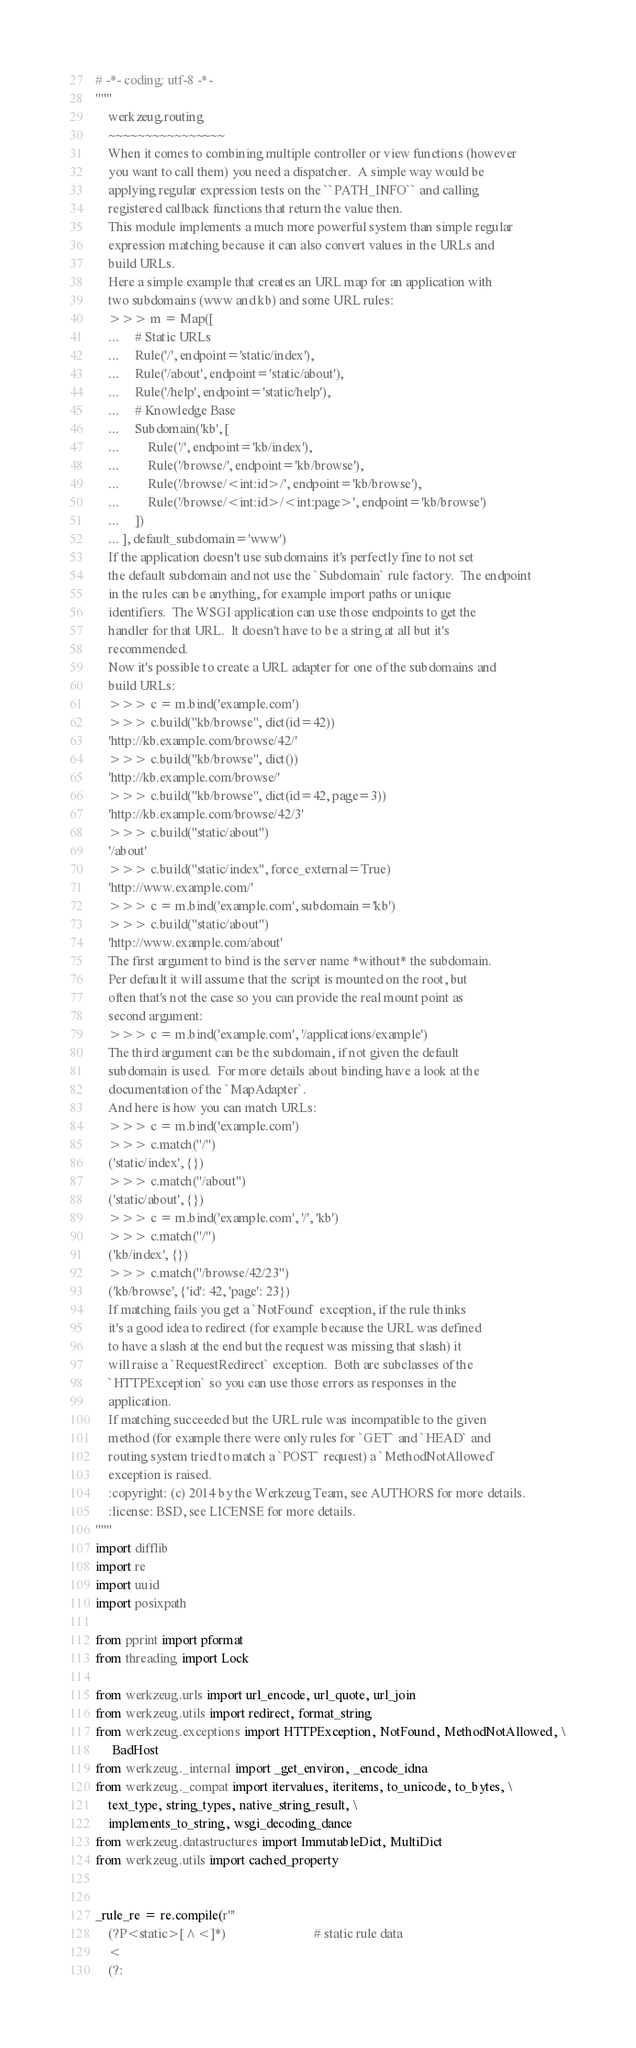<code> <loc_0><loc_0><loc_500><loc_500><_Python_># -*- coding: utf-8 -*-
"""
    werkzeug.routing
    ~~~~~~~~~~~~~~~~
    When it comes to combining multiple controller or view functions (however
    you want to call them) you need a dispatcher.  A simple way would be
    applying regular expression tests on the ``PATH_INFO`` and calling
    registered callback functions that return the value then.
    This module implements a much more powerful system than simple regular
    expression matching because it can also convert values in the URLs and
    build URLs.
    Here a simple example that creates an URL map for an application with
    two subdomains (www and kb) and some URL rules:
    >>> m = Map([
    ...     # Static URLs
    ...     Rule('/', endpoint='static/index'),
    ...     Rule('/about', endpoint='static/about'),
    ...     Rule('/help', endpoint='static/help'),
    ...     # Knowledge Base
    ...     Subdomain('kb', [
    ...         Rule('/', endpoint='kb/index'),
    ...         Rule('/browse/', endpoint='kb/browse'),
    ...         Rule('/browse/<int:id>/', endpoint='kb/browse'),
    ...         Rule('/browse/<int:id>/<int:page>', endpoint='kb/browse')
    ...     ])
    ... ], default_subdomain='www')
    If the application doesn't use subdomains it's perfectly fine to not set
    the default subdomain and not use the `Subdomain` rule factory.  The endpoint
    in the rules can be anything, for example import paths or unique
    identifiers.  The WSGI application can use those endpoints to get the
    handler for that URL.  It doesn't have to be a string at all but it's
    recommended.
    Now it's possible to create a URL adapter for one of the subdomains and
    build URLs:
    >>> c = m.bind('example.com')
    >>> c.build("kb/browse", dict(id=42))
    'http://kb.example.com/browse/42/'
    >>> c.build("kb/browse", dict())
    'http://kb.example.com/browse/'
    >>> c.build("kb/browse", dict(id=42, page=3))
    'http://kb.example.com/browse/42/3'
    >>> c.build("static/about")
    '/about'
    >>> c.build("static/index", force_external=True)
    'http://www.example.com/'
    >>> c = m.bind('example.com', subdomain='kb')
    >>> c.build("static/about")
    'http://www.example.com/about'
    The first argument to bind is the server name *without* the subdomain.
    Per default it will assume that the script is mounted on the root, but
    often that's not the case so you can provide the real mount point as
    second argument:
    >>> c = m.bind('example.com', '/applications/example')
    The third argument can be the subdomain, if not given the default
    subdomain is used.  For more details about binding have a look at the
    documentation of the `MapAdapter`.
    And here is how you can match URLs:
    >>> c = m.bind('example.com')
    >>> c.match("/")
    ('static/index', {})
    >>> c.match("/about")
    ('static/about', {})
    >>> c = m.bind('example.com', '/', 'kb')
    >>> c.match("/")
    ('kb/index', {})
    >>> c.match("/browse/42/23")
    ('kb/browse', {'id': 42, 'page': 23})
    If matching fails you get a `NotFound` exception, if the rule thinks
    it's a good idea to redirect (for example because the URL was defined
    to have a slash at the end but the request was missing that slash) it
    will raise a `RequestRedirect` exception.  Both are subclasses of the
    `HTTPException` so you can use those errors as responses in the
    application.
    If matching succeeded but the URL rule was incompatible to the given
    method (for example there were only rules for `GET` and `HEAD` and
    routing system tried to match a `POST` request) a `MethodNotAllowed`
    exception is raised.
    :copyright: (c) 2014 by the Werkzeug Team, see AUTHORS for more details.
    :license: BSD, see LICENSE for more details.
"""
import difflib
import re
import uuid
import posixpath

from pprint import pformat
from threading import Lock

from werkzeug.urls import url_encode, url_quote, url_join
from werkzeug.utils import redirect, format_string
from werkzeug.exceptions import HTTPException, NotFound, MethodNotAllowed, \
     BadHost
from werkzeug._internal import _get_environ, _encode_idna
from werkzeug._compat import itervalues, iteritems, to_unicode, to_bytes, \
    text_type, string_types, native_string_result, \
    implements_to_string, wsgi_decoding_dance
from werkzeug.datastructures import ImmutableDict, MultiDict
from werkzeug.utils import cached_property


_rule_re = re.compile(r'''
    (?P<static>[^<]*)                           # static rule data
    <
    (?:</code> 